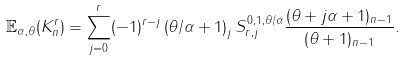<formula> <loc_0><loc_0><loc_500><loc_500>\mathbb { E } _ { \alpha , \theta } ( K _ { n } ^ { r } ) = \sum _ { j = 0 } ^ { r } ( - 1 ) ^ { r - j } \left ( \theta / \alpha + 1 \right ) _ { j } S _ { r , j } ^ { 0 , 1 , \theta / \alpha } \frac { ( \theta + j \alpha + 1 ) _ { n - 1 } } { ( \theta + 1 ) _ { n - 1 } } .</formula> 